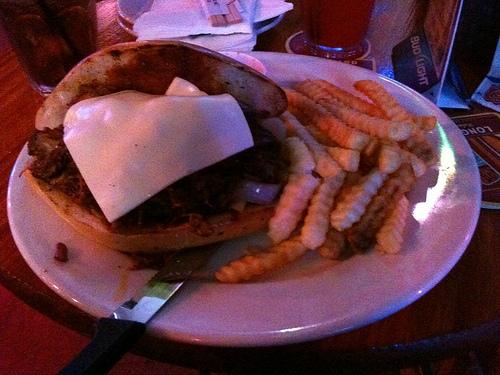How many pieces of cheese are there?
Short answer required. 1. What popular condiment goes with the food on the right?
Quick response, please. Ketchup. What food is on the plate?
Be succinct. Hamburger and fries. 